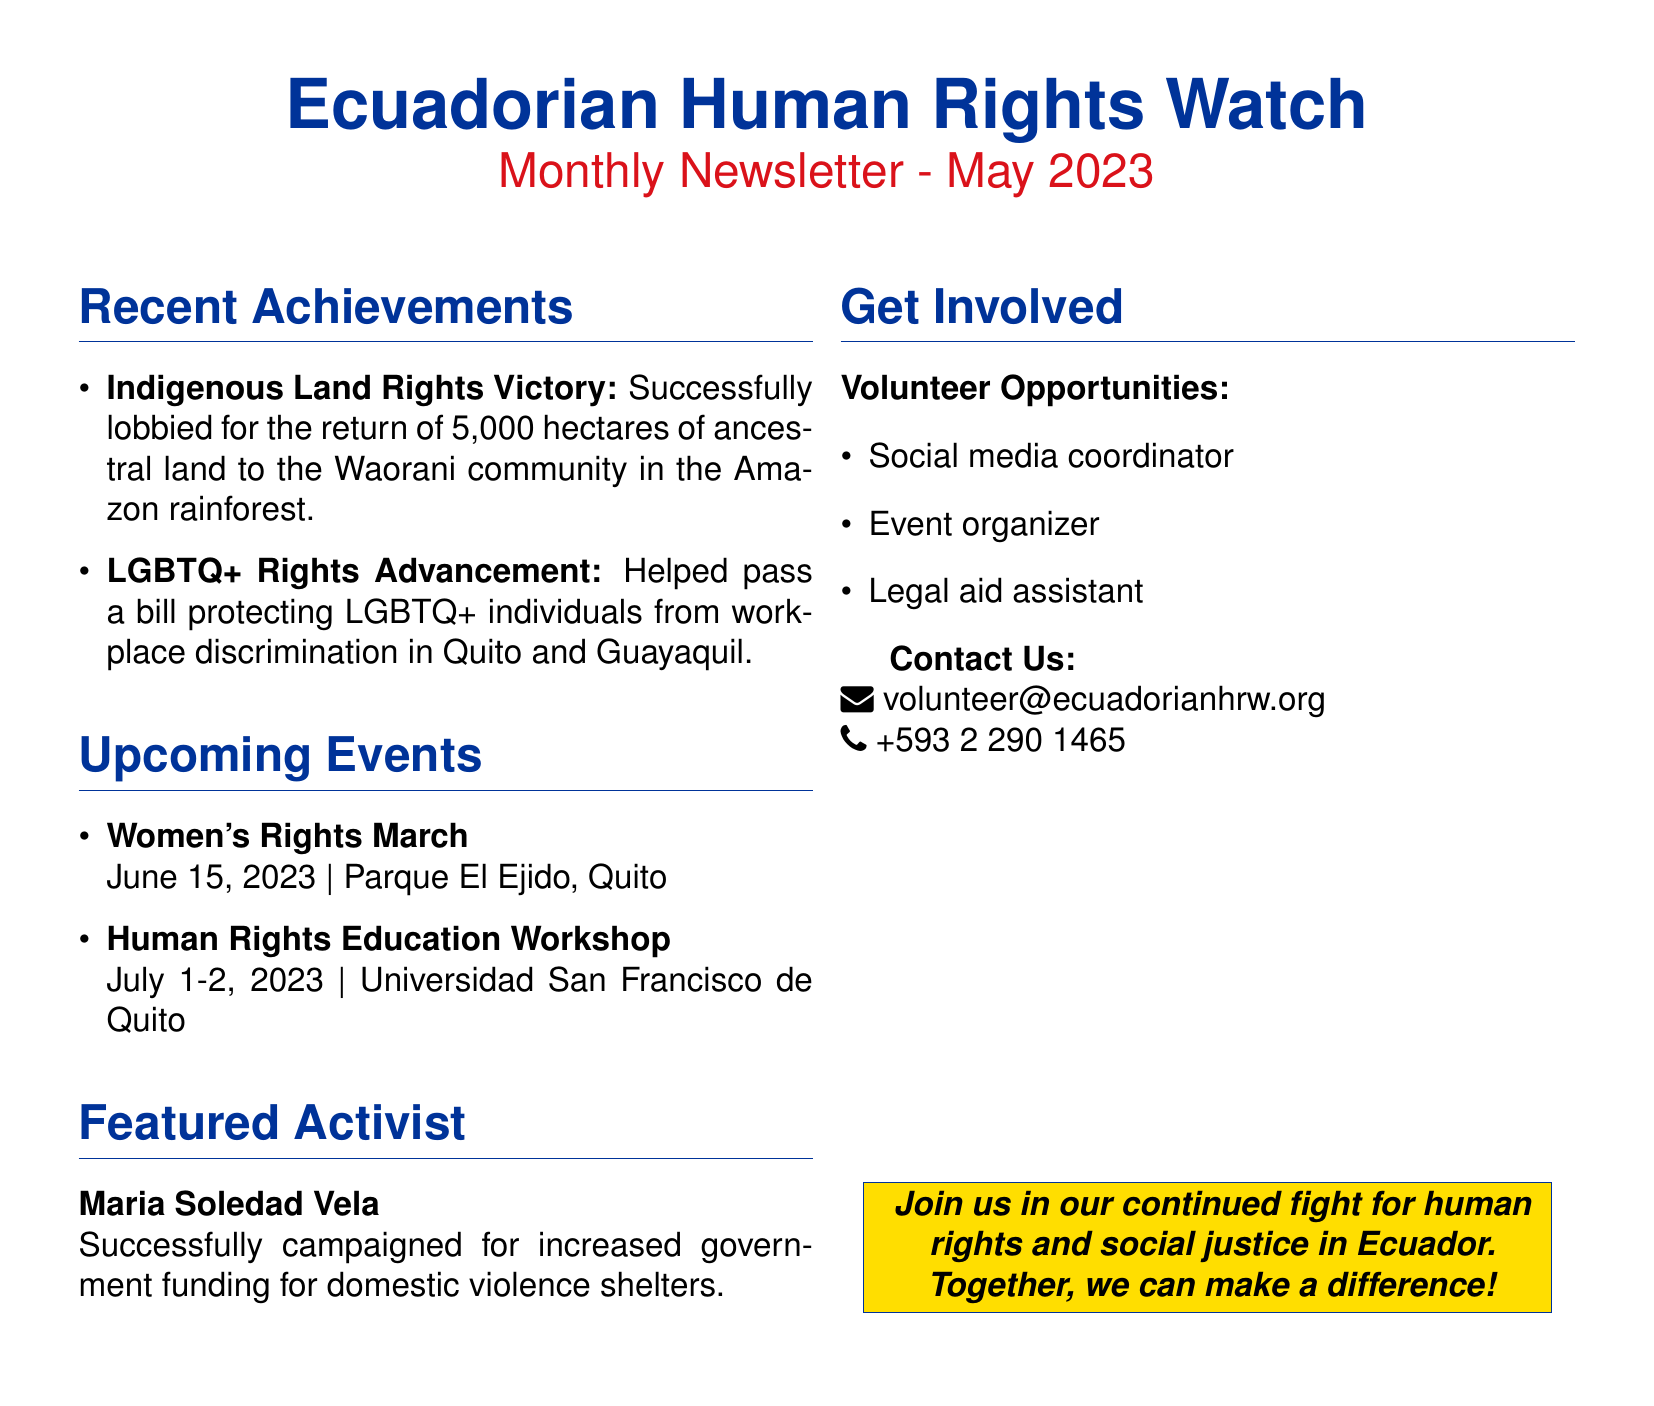What is the name of the organization? The name of the organization is stated at the top of the document.
Answer: Ecuadorian Human Rights Watch What date is the newsletter published? The publication date is mentioned in the document title.
Answer: May 2023 What is the total area of land returned to the Waorani community? This information highlights a specific achievement listed in the document.
Answer: 5,000 hectares On what date is the Women's Rights March scheduled? The date of the event is clearly listed under upcoming events.
Answer: June 15, 2023 Who is the featured activist in the newsletter? The name of the featured activist is specified in the document.
Answer: Maria Soledad Vela What are the types of volunteer opportunities mentioned? This information is listed under the "Get Involved" section of the document.
Answer: Social media coordinator, Event organizer, Legal aid assistant Where will the Human Rights Education Workshop take place? The location of the workshop is provided in the events section of the document.
Answer: Universidad San Francisco de Quito How many days will the Human Rights Education Workshop last? The duration of the workshop is mentioned in the document.
Answer: 2 days What is the email address for contacting the organization? The contact information is provided at the end of the document.
Answer: volunteer@ecuadorianhrw.org 